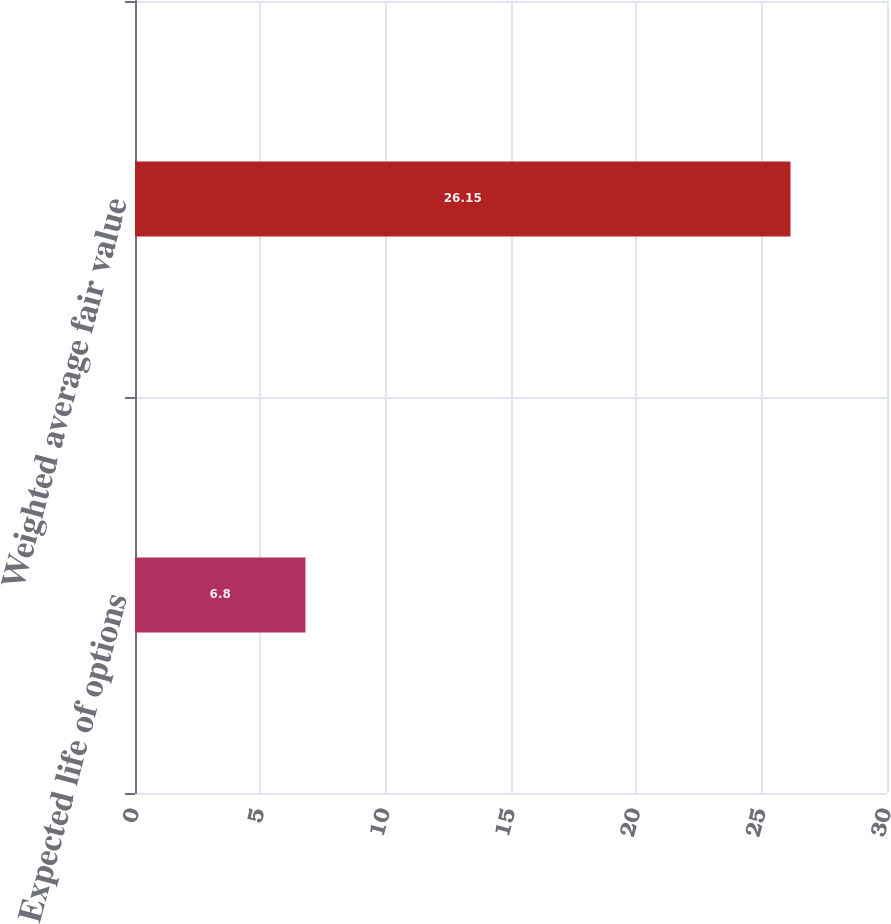Convert chart to OTSL. <chart><loc_0><loc_0><loc_500><loc_500><bar_chart><fcel>Expected life of options<fcel>Weighted average fair value<nl><fcel>6.8<fcel>26.15<nl></chart> 